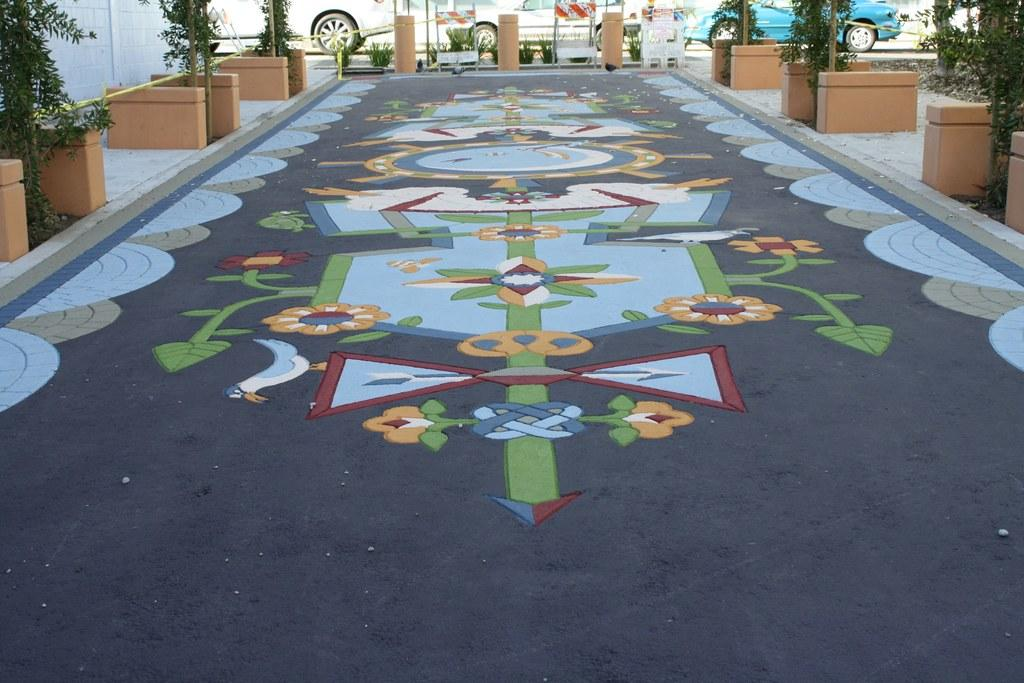What type of living organisms can be seen in the image? Plants can be seen in the image. What is located on the floor in the image? There is a painting on the floor in the image. What can be seen in the background of the image? Vehicles are visible in the background of the image. What instrument is the mother playing in the image? There is no mother or instrument present in the image. What type of pump is visible in the image? There is no pump present in the image. 